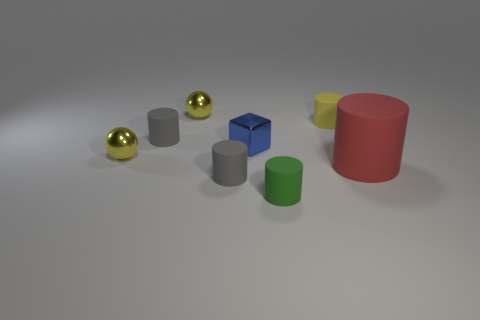What number of purple rubber blocks are there?
Provide a short and direct response. 0. What number of cylinders are small yellow objects or big red things?
Your response must be concise. 2. How many yellow spheres are on the left side of the yellow sphere that is on the left side of the small ball behind the small metallic block?
Make the answer very short. 0. There is a cube that is the same size as the green rubber cylinder; what is its color?
Ensure brevity in your answer.  Blue. Is the number of large rubber cylinders that are in front of the green rubber cylinder greater than the number of brown metal cylinders?
Provide a short and direct response. No. Does the small green cylinder have the same material as the red cylinder?
Give a very brief answer. Yes. What number of things are matte objects that are in front of the big red thing or big matte things?
Your answer should be very brief. 3. How many other objects are the same size as the red rubber cylinder?
Give a very brief answer. 0. Are there the same number of yellow metallic spheres that are in front of the metallic cube and large red objects behind the red object?
Keep it short and to the point. No. What is the color of the other big thing that is the same shape as the green rubber thing?
Offer a very short reply. Red. 